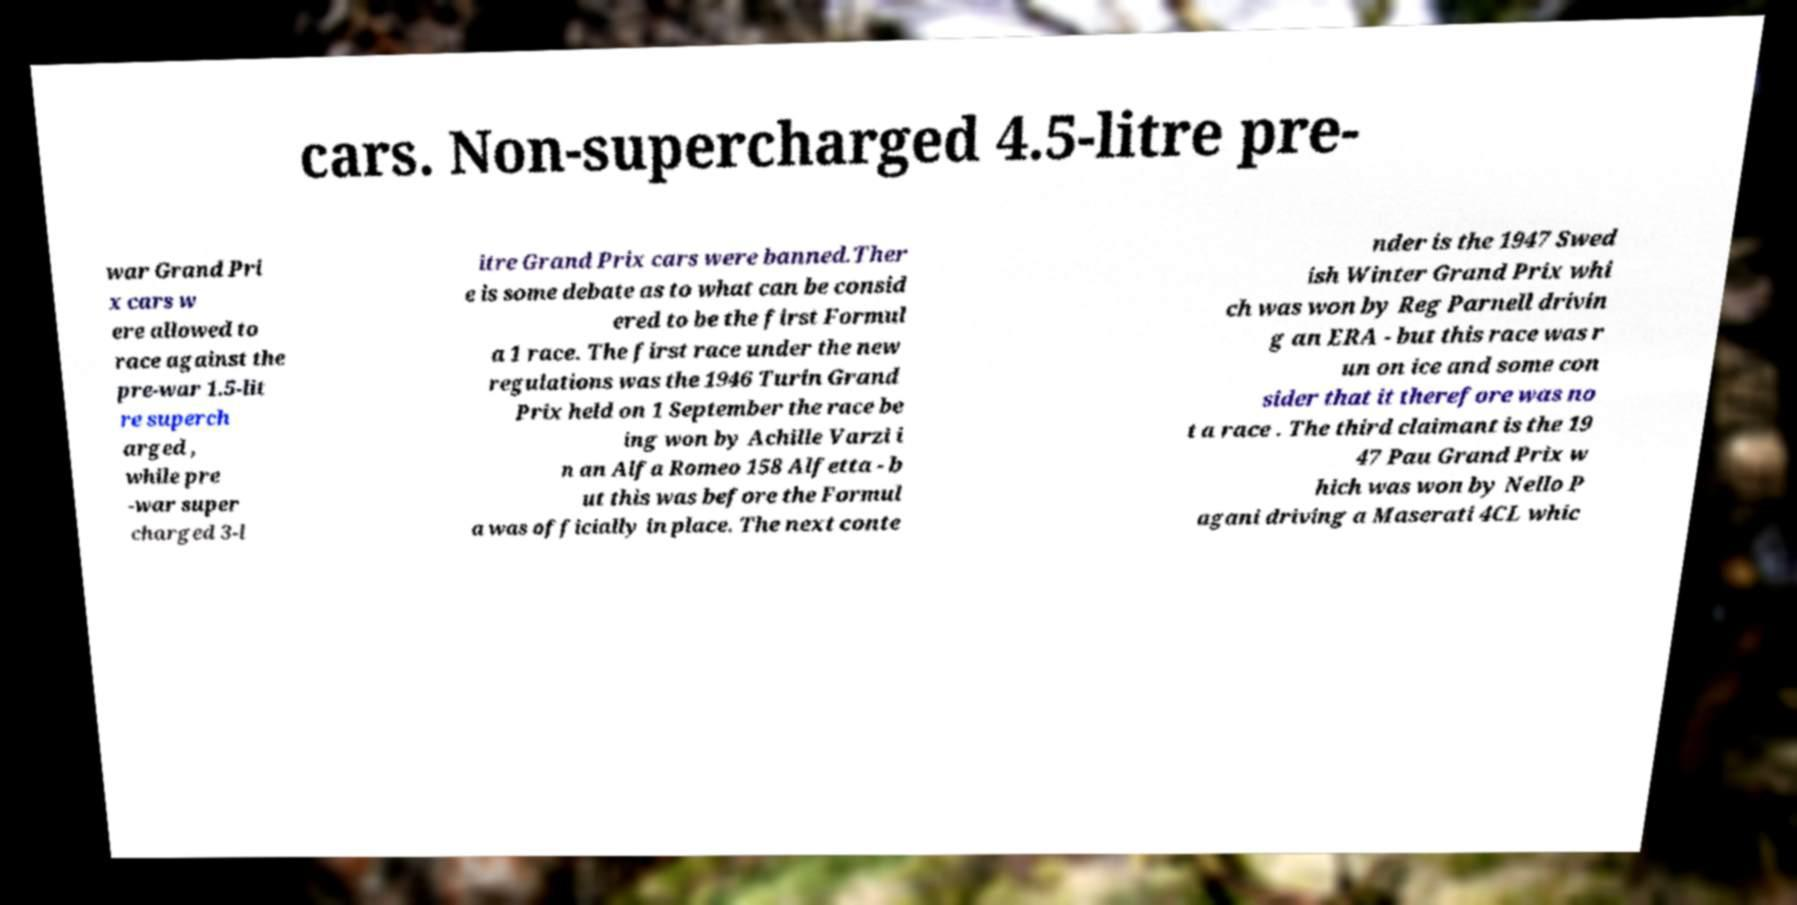For documentation purposes, I need the text within this image transcribed. Could you provide that? cars. Non-supercharged 4.5-litre pre- war Grand Pri x cars w ere allowed to race against the pre-war 1.5-lit re superch arged , while pre -war super charged 3-l itre Grand Prix cars were banned.Ther e is some debate as to what can be consid ered to be the first Formul a 1 race. The first race under the new regulations was the 1946 Turin Grand Prix held on 1 September the race be ing won by Achille Varzi i n an Alfa Romeo 158 Alfetta - b ut this was before the Formul a was officially in place. The next conte nder is the 1947 Swed ish Winter Grand Prix whi ch was won by Reg Parnell drivin g an ERA - but this race was r un on ice and some con sider that it therefore was no t a race . The third claimant is the 19 47 Pau Grand Prix w hich was won by Nello P agani driving a Maserati 4CL whic 